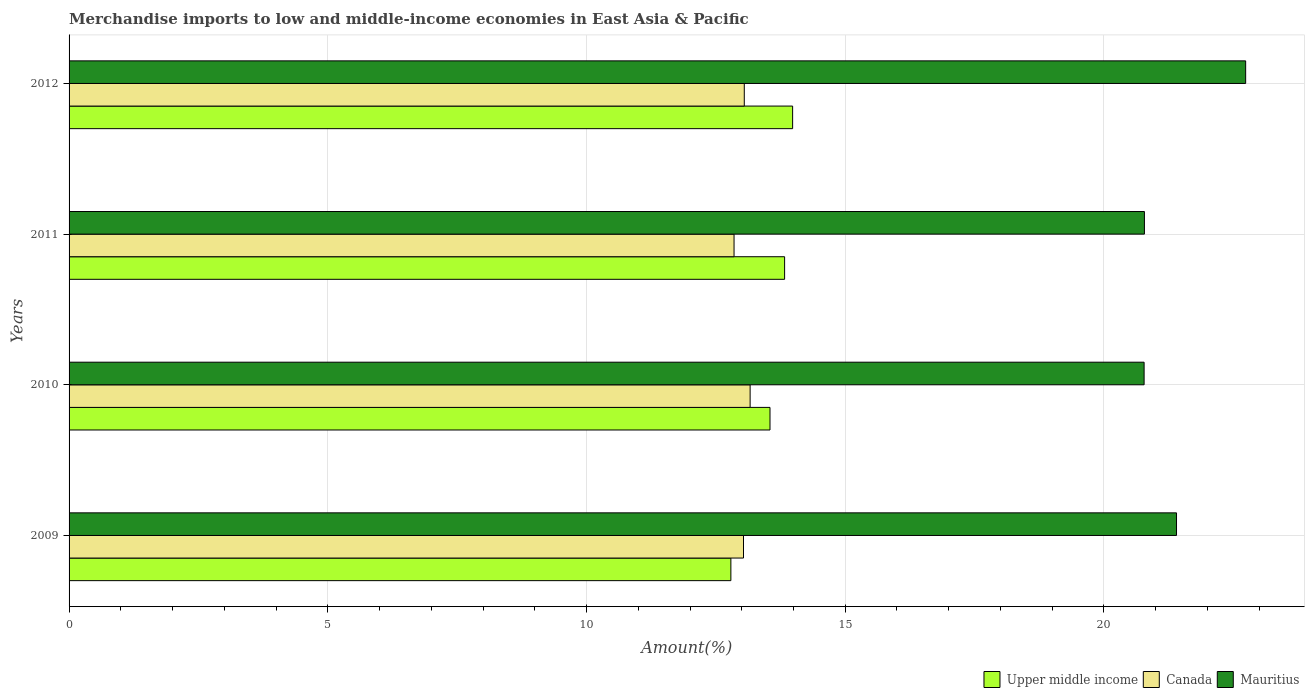How many groups of bars are there?
Give a very brief answer. 4. Are the number of bars per tick equal to the number of legend labels?
Offer a terse response. Yes. How many bars are there on the 3rd tick from the bottom?
Offer a terse response. 3. What is the label of the 2nd group of bars from the top?
Your response must be concise. 2011. What is the percentage of amount earned from merchandise imports in Canada in 2012?
Ensure brevity in your answer.  13.05. Across all years, what is the maximum percentage of amount earned from merchandise imports in Canada?
Offer a very short reply. 13.16. Across all years, what is the minimum percentage of amount earned from merchandise imports in Upper middle income?
Keep it short and to the point. 12.79. What is the total percentage of amount earned from merchandise imports in Upper middle income in the graph?
Ensure brevity in your answer.  54.15. What is the difference between the percentage of amount earned from merchandise imports in Mauritius in 2009 and that in 2010?
Ensure brevity in your answer.  0.63. What is the difference between the percentage of amount earned from merchandise imports in Upper middle income in 2011 and the percentage of amount earned from merchandise imports in Mauritius in 2012?
Offer a terse response. -8.91. What is the average percentage of amount earned from merchandise imports in Mauritius per year?
Keep it short and to the point. 21.42. In the year 2010, what is the difference between the percentage of amount earned from merchandise imports in Mauritius and percentage of amount earned from merchandise imports in Upper middle income?
Provide a short and direct response. 7.23. In how many years, is the percentage of amount earned from merchandise imports in Upper middle income greater than 22 %?
Provide a succinct answer. 0. What is the ratio of the percentage of amount earned from merchandise imports in Mauritius in 2009 to that in 2011?
Your answer should be very brief. 1.03. Is the percentage of amount earned from merchandise imports in Canada in 2009 less than that in 2012?
Provide a succinct answer. Yes. Is the difference between the percentage of amount earned from merchandise imports in Mauritius in 2011 and 2012 greater than the difference between the percentage of amount earned from merchandise imports in Upper middle income in 2011 and 2012?
Keep it short and to the point. No. What is the difference between the highest and the second highest percentage of amount earned from merchandise imports in Mauritius?
Provide a succinct answer. 1.34. What is the difference between the highest and the lowest percentage of amount earned from merchandise imports in Upper middle income?
Offer a terse response. 1.19. What does the 1st bar from the top in 2011 represents?
Offer a terse response. Mauritius. What does the 3rd bar from the bottom in 2009 represents?
Your answer should be compact. Mauritius. Is it the case that in every year, the sum of the percentage of amount earned from merchandise imports in Upper middle income and percentage of amount earned from merchandise imports in Canada is greater than the percentage of amount earned from merchandise imports in Mauritius?
Your response must be concise. Yes. How many bars are there?
Your answer should be compact. 12. Are the values on the major ticks of X-axis written in scientific E-notation?
Keep it short and to the point. No. Does the graph contain any zero values?
Your response must be concise. No. Where does the legend appear in the graph?
Ensure brevity in your answer.  Bottom right. How are the legend labels stacked?
Make the answer very short. Horizontal. What is the title of the graph?
Provide a short and direct response. Merchandise imports to low and middle-income economies in East Asia & Pacific. What is the label or title of the X-axis?
Give a very brief answer. Amount(%). What is the label or title of the Y-axis?
Offer a very short reply. Years. What is the Amount(%) in Upper middle income in 2009?
Offer a very short reply. 12.79. What is the Amount(%) in Canada in 2009?
Make the answer very short. 13.03. What is the Amount(%) of Mauritius in 2009?
Your answer should be compact. 21.4. What is the Amount(%) of Upper middle income in 2010?
Provide a short and direct response. 13.55. What is the Amount(%) in Canada in 2010?
Provide a short and direct response. 13.16. What is the Amount(%) of Mauritius in 2010?
Your answer should be compact. 20.78. What is the Amount(%) in Upper middle income in 2011?
Offer a terse response. 13.83. What is the Amount(%) in Canada in 2011?
Keep it short and to the point. 12.85. What is the Amount(%) in Mauritius in 2011?
Keep it short and to the point. 20.78. What is the Amount(%) in Upper middle income in 2012?
Your answer should be very brief. 13.98. What is the Amount(%) in Canada in 2012?
Your answer should be compact. 13.05. What is the Amount(%) in Mauritius in 2012?
Give a very brief answer. 22.74. Across all years, what is the maximum Amount(%) of Upper middle income?
Offer a terse response. 13.98. Across all years, what is the maximum Amount(%) of Canada?
Offer a terse response. 13.16. Across all years, what is the maximum Amount(%) of Mauritius?
Keep it short and to the point. 22.74. Across all years, what is the minimum Amount(%) in Upper middle income?
Provide a short and direct response. 12.79. Across all years, what is the minimum Amount(%) of Canada?
Provide a short and direct response. 12.85. Across all years, what is the minimum Amount(%) of Mauritius?
Provide a succinct answer. 20.78. What is the total Amount(%) in Upper middle income in the graph?
Your response must be concise. 54.15. What is the total Amount(%) in Canada in the graph?
Make the answer very short. 52.1. What is the total Amount(%) of Mauritius in the graph?
Offer a very short reply. 85.7. What is the difference between the Amount(%) in Upper middle income in 2009 and that in 2010?
Ensure brevity in your answer.  -0.76. What is the difference between the Amount(%) in Canada in 2009 and that in 2010?
Your response must be concise. -0.13. What is the difference between the Amount(%) of Mauritius in 2009 and that in 2010?
Your answer should be compact. 0.63. What is the difference between the Amount(%) in Upper middle income in 2009 and that in 2011?
Give a very brief answer. -1.04. What is the difference between the Amount(%) in Canada in 2009 and that in 2011?
Your answer should be very brief. 0.18. What is the difference between the Amount(%) in Mauritius in 2009 and that in 2011?
Provide a short and direct response. 0.62. What is the difference between the Amount(%) in Upper middle income in 2009 and that in 2012?
Ensure brevity in your answer.  -1.19. What is the difference between the Amount(%) of Canada in 2009 and that in 2012?
Provide a succinct answer. -0.01. What is the difference between the Amount(%) in Mauritius in 2009 and that in 2012?
Provide a short and direct response. -1.34. What is the difference between the Amount(%) in Upper middle income in 2010 and that in 2011?
Make the answer very short. -0.28. What is the difference between the Amount(%) of Canada in 2010 and that in 2011?
Offer a terse response. 0.31. What is the difference between the Amount(%) in Mauritius in 2010 and that in 2011?
Your response must be concise. -0.01. What is the difference between the Amount(%) of Upper middle income in 2010 and that in 2012?
Your answer should be very brief. -0.44. What is the difference between the Amount(%) of Canada in 2010 and that in 2012?
Provide a succinct answer. 0.11. What is the difference between the Amount(%) in Mauritius in 2010 and that in 2012?
Offer a terse response. -1.96. What is the difference between the Amount(%) in Upper middle income in 2011 and that in 2012?
Make the answer very short. -0.15. What is the difference between the Amount(%) in Canada in 2011 and that in 2012?
Your response must be concise. -0.2. What is the difference between the Amount(%) in Mauritius in 2011 and that in 2012?
Offer a terse response. -1.96. What is the difference between the Amount(%) in Upper middle income in 2009 and the Amount(%) in Canada in 2010?
Provide a succinct answer. -0.37. What is the difference between the Amount(%) of Upper middle income in 2009 and the Amount(%) of Mauritius in 2010?
Keep it short and to the point. -7.99. What is the difference between the Amount(%) in Canada in 2009 and the Amount(%) in Mauritius in 2010?
Provide a short and direct response. -7.74. What is the difference between the Amount(%) in Upper middle income in 2009 and the Amount(%) in Canada in 2011?
Keep it short and to the point. -0.06. What is the difference between the Amount(%) in Upper middle income in 2009 and the Amount(%) in Mauritius in 2011?
Make the answer very short. -7.99. What is the difference between the Amount(%) in Canada in 2009 and the Amount(%) in Mauritius in 2011?
Ensure brevity in your answer.  -7.75. What is the difference between the Amount(%) of Upper middle income in 2009 and the Amount(%) of Canada in 2012?
Give a very brief answer. -0.26. What is the difference between the Amount(%) in Upper middle income in 2009 and the Amount(%) in Mauritius in 2012?
Keep it short and to the point. -9.95. What is the difference between the Amount(%) of Canada in 2009 and the Amount(%) of Mauritius in 2012?
Provide a short and direct response. -9.7. What is the difference between the Amount(%) in Upper middle income in 2010 and the Amount(%) in Canada in 2011?
Your answer should be very brief. 0.69. What is the difference between the Amount(%) of Upper middle income in 2010 and the Amount(%) of Mauritius in 2011?
Offer a very short reply. -7.24. What is the difference between the Amount(%) in Canada in 2010 and the Amount(%) in Mauritius in 2011?
Offer a very short reply. -7.62. What is the difference between the Amount(%) of Upper middle income in 2010 and the Amount(%) of Canada in 2012?
Keep it short and to the point. 0.5. What is the difference between the Amount(%) of Upper middle income in 2010 and the Amount(%) of Mauritius in 2012?
Your answer should be very brief. -9.19. What is the difference between the Amount(%) in Canada in 2010 and the Amount(%) in Mauritius in 2012?
Ensure brevity in your answer.  -9.58. What is the difference between the Amount(%) of Upper middle income in 2011 and the Amount(%) of Canada in 2012?
Your answer should be compact. 0.78. What is the difference between the Amount(%) in Upper middle income in 2011 and the Amount(%) in Mauritius in 2012?
Keep it short and to the point. -8.91. What is the difference between the Amount(%) of Canada in 2011 and the Amount(%) of Mauritius in 2012?
Provide a succinct answer. -9.89. What is the average Amount(%) in Upper middle income per year?
Your answer should be very brief. 13.54. What is the average Amount(%) in Canada per year?
Your answer should be compact. 13.02. What is the average Amount(%) of Mauritius per year?
Offer a terse response. 21.42. In the year 2009, what is the difference between the Amount(%) of Upper middle income and Amount(%) of Canada?
Provide a short and direct response. -0.24. In the year 2009, what is the difference between the Amount(%) of Upper middle income and Amount(%) of Mauritius?
Keep it short and to the point. -8.61. In the year 2009, what is the difference between the Amount(%) of Canada and Amount(%) of Mauritius?
Keep it short and to the point. -8.37. In the year 2010, what is the difference between the Amount(%) of Upper middle income and Amount(%) of Canada?
Your response must be concise. 0.38. In the year 2010, what is the difference between the Amount(%) in Upper middle income and Amount(%) in Mauritius?
Offer a very short reply. -7.23. In the year 2010, what is the difference between the Amount(%) of Canada and Amount(%) of Mauritius?
Keep it short and to the point. -7.61. In the year 2011, what is the difference between the Amount(%) in Upper middle income and Amount(%) in Canada?
Give a very brief answer. 0.98. In the year 2011, what is the difference between the Amount(%) of Upper middle income and Amount(%) of Mauritius?
Keep it short and to the point. -6.95. In the year 2011, what is the difference between the Amount(%) in Canada and Amount(%) in Mauritius?
Your response must be concise. -7.93. In the year 2012, what is the difference between the Amount(%) of Upper middle income and Amount(%) of Canada?
Your answer should be compact. 0.93. In the year 2012, what is the difference between the Amount(%) in Upper middle income and Amount(%) in Mauritius?
Make the answer very short. -8.76. In the year 2012, what is the difference between the Amount(%) in Canada and Amount(%) in Mauritius?
Provide a short and direct response. -9.69. What is the ratio of the Amount(%) of Upper middle income in 2009 to that in 2010?
Offer a very short reply. 0.94. What is the ratio of the Amount(%) in Canada in 2009 to that in 2010?
Keep it short and to the point. 0.99. What is the ratio of the Amount(%) in Mauritius in 2009 to that in 2010?
Keep it short and to the point. 1.03. What is the ratio of the Amount(%) in Upper middle income in 2009 to that in 2011?
Provide a short and direct response. 0.92. What is the ratio of the Amount(%) of Canada in 2009 to that in 2011?
Offer a terse response. 1.01. What is the ratio of the Amount(%) in Mauritius in 2009 to that in 2011?
Give a very brief answer. 1.03. What is the ratio of the Amount(%) in Upper middle income in 2009 to that in 2012?
Your answer should be compact. 0.91. What is the ratio of the Amount(%) of Canada in 2009 to that in 2012?
Your answer should be compact. 1. What is the ratio of the Amount(%) of Mauritius in 2009 to that in 2012?
Your response must be concise. 0.94. What is the ratio of the Amount(%) in Upper middle income in 2010 to that in 2011?
Make the answer very short. 0.98. What is the ratio of the Amount(%) in Canada in 2010 to that in 2011?
Keep it short and to the point. 1.02. What is the ratio of the Amount(%) of Upper middle income in 2010 to that in 2012?
Ensure brevity in your answer.  0.97. What is the ratio of the Amount(%) in Canada in 2010 to that in 2012?
Provide a succinct answer. 1.01. What is the ratio of the Amount(%) in Mauritius in 2010 to that in 2012?
Give a very brief answer. 0.91. What is the ratio of the Amount(%) in Upper middle income in 2011 to that in 2012?
Make the answer very short. 0.99. What is the ratio of the Amount(%) in Canada in 2011 to that in 2012?
Make the answer very short. 0.98. What is the ratio of the Amount(%) in Mauritius in 2011 to that in 2012?
Keep it short and to the point. 0.91. What is the difference between the highest and the second highest Amount(%) in Upper middle income?
Keep it short and to the point. 0.15. What is the difference between the highest and the second highest Amount(%) of Canada?
Offer a terse response. 0.11. What is the difference between the highest and the second highest Amount(%) in Mauritius?
Your answer should be very brief. 1.34. What is the difference between the highest and the lowest Amount(%) of Upper middle income?
Give a very brief answer. 1.19. What is the difference between the highest and the lowest Amount(%) of Canada?
Keep it short and to the point. 0.31. What is the difference between the highest and the lowest Amount(%) of Mauritius?
Your response must be concise. 1.96. 